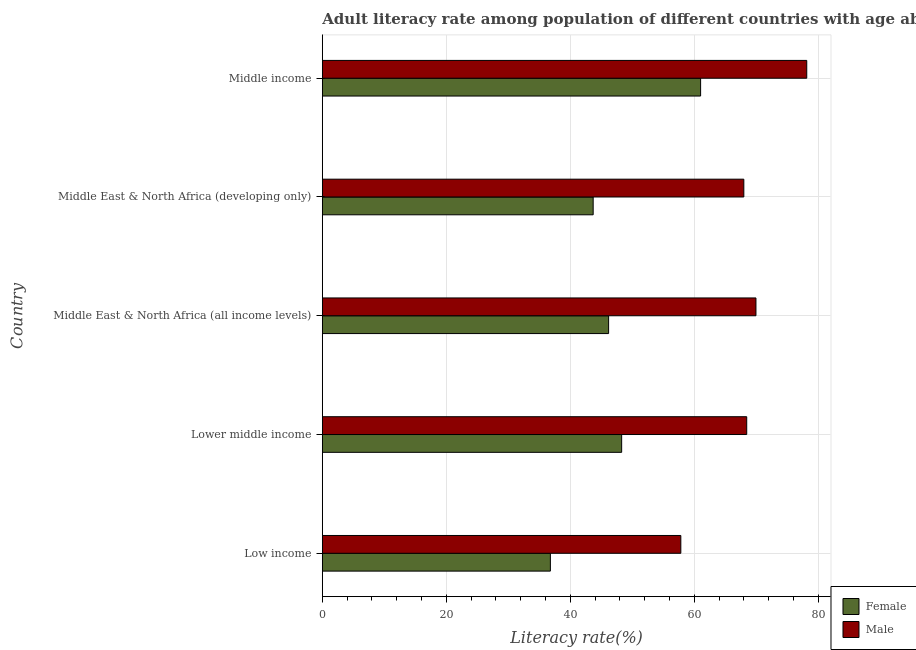How many different coloured bars are there?
Offer a very short reply. 2. How many bars are there on the 3rd tick from the bottom?
Give a very brief answer. 2. What is the label of the 4th group of bars from the top?
Make the answer very short. Lower middle income. In how many cases, is the number of bars for a given country not equal to the number of legend labels?
Your answer should be very brief. 0. What is the female adult literacy rate in Middle East & North Africa (developing only)?
Keep it short and to the point. 43.7. Across all countries, what is the maximum male adult literacy rate?
Keep it short and to the point. 78.16. Across all countries, what is the minimum male adult literacy rate?
Your response must be concise. 57.84. In which country was the female adult literacy rate maximum?
Ensure brevity in your answer.  Middle income. In which country was the female adult literacy rate minimum?
Ensure brevity in your answer.  Low income. What is the total male adult literacy rate in the graph?
Your response must be concise. 342.45. What is the difference between the female adult literacy rate in Low income and that in Lower middle income?
Provide a short and direct response. -11.5. What is the difference between the female adult literacy rate in Middle East & North Africa (developing only) and the male adult literacy rate in Low income?
Provide a short and direct response. -14.14. What is the average male adult literacy rate per country?
Ensure brevity in your answer.  68.49. What is the difference between the male adult literacy rate and female adult literacy rate in Middle income?
Offer a very short reply. 17.12. In how many countries, is the male adult literacy rate greater than 40 %?
Keep it short and to the point. 5. What is the ratio of the male adult literacy rate in Lower middle income to that in Middle income?
Make the answer very short. 0.88. What is the difference between the highest and the second highest male adult literacy rate?
Offer a terse response. 8.2. What is the difference between the highest and the lowest female adult literacy rate?
Offer a very short reply. 24.24. Is the sum of the male adult literacy rate in Low income and Middle East & North Africa (developing only) greater than the maximum female adult literacy rate across all countries?
Offer a terse response. Yes. How many bars are there?
Provide a succinct answer. 10. Are the values on the major ticks of X-axis written in scientific E-notation?
Provide a short and direct response. No. Does the graph contain any zero values?
Your answer should be compact. No. Does the graph contain grids?
Keep it short and to the point. Yes. How many legend labels are there?
Offer a very short reply. 2. How are the legend labels stacked?
Provide a succinct answer. Vertical. What is the title of the graph?
Your answer should be very brief. Adult literacy rate among population of different countries with age above 15years. Does "Diarrhea" appear as one of the legend labels in the graph?
Ensure brevity in your answer.  No. What is the label or title of the X-axis?
Offer a very short reply. Literacy rate(%). What is the Literacy rate(%) of Female in Low income?
Keep it short and to the point. 36.79. What is the Literacy rate(%) of Male in Low income?
Offer a very short reply. 57.84. What is the Literacy rate(%) of Female in Lower middle income?
Provide a short and direct response. 48.3. What is the Literacy rate(%) of Male in Lower middle income?
Your answer should be very brief. 68.47. What is the Literacy rate(%) in Female in Middle East & North Africa (all income levels)?
Provide a short and direct response. 46.19. What is the Literacy rate(%) of Male in Middle East & North Africa (all income levels)?
Keep it short and to the point. 69.96. What is the Literacy rate(%) of Female in Middle East & North Africa (developing only)?
Your response must be concise. 43.7. What is the Literacy rate(%) of Male in Middle East & North Africa (developing only)?
Provide a succinct answer. 68.01. What is the Literacy rate(%) of Female in Middle income?
Keep it short and to the point. 61.04. What is the Literacy rate(%) in Male in Middle income?
Offer a terse response. 78.16. Across all countries, what is the maximum Literacy rate(%) of Female?
Offer a terse response. 61.04. Across all countries, what is the maximum Literacy rate(%) in Male?
Offer a terse response. 78.16. Across all countries, what is the minimum Literacy rate(%) in Female?
Your answer should be very brief. 36.79. Across all countries, what is the minimum Literacy rate(%) of Male?
Make the answer very short. 57.84. What is the total Literacy rate(%) of Female in the graph?
Give a very brief answer. 236.01. What is the total Literacy rate(%) of Male in the graph?
Provide a short and direct response. 342.45. What is the difference between the Literacy rate(%) of Female in Low income and that in Lower middle income?
Provide a succinct answer. -11.5. What is the difference between the Literacy rate(%) in Male in Low income and that in Lower middle income?
Ensure brevity in your answer.  -10.63. What is the difference between the Literacy rate(%) of Female in Low income and that in Middle East & North Africa (all income levels)?
Your response must be concise. -9.4. What is the difference between the Literacy rate(%) in Male in Low income and that in Middle East & North Africa (all income levels)?
Your response must be concise. -12.12. What is the difference between the Literacy rate(%) of Female in Low income and that in Middle East & North Africa (developing only)?
Make the answer very short. -6.91. What is the difference between the Literacy rate(%) of Male in Low income and that in Middle East & North Africa (developing only)?
Give a very brief answer. -10.16. What is the difference between the Literacy rate(%) of Female in Low income and that in Middle income?
Give a very brief answer. -24.24. What is the difference between the Literacy rate(%) of Male in Low income and that in Middle income?
Your response must be concise. -20.32. What is the difference between the Literacy rate(%) in Female in Lower middle income and that in Middle East & North Africa (all income levels)?
Provide a short and direct response. 2.11. What is the difference between the Literacy rate(%) of Male in Lower middle income and that in Middle East & North Africa (all income levels)?
Provide a succinct answer. -1.49. What is the difference between the Literacy rate(%) in Female in Lower middle income and that in Middle East & North Africa (developing only)?
Make the answer very short. 4.6. What is the difference between the Literacy rate(%) of Male in Lower middle income and that in Middle East & North Africa (developing only)?
Provide a succinct answer. 0.47. What is the difference between the Literacy rate(%) in Female in Lower middle income and that in Middle income?
Give a very brief answer. -12.74. What is the difference between the Literacy rate(%) in Male in Lower middle income and that in Middle income?
Provide a succinct answer. -9.69. What is the difference between the Literacy rate(%) of Female in Middle East & North Africa (all income levels) and that in Middle East & North Africa (developing only)?
Offer a very short reply. 2.49. What is the difference between the Literacy rate(%) of Male in Middle East & North Africa (all income levels) and that in Middle East & North Africa (developing only)?
Provide a short and direct response. 1.96. What is the difference between the Literacy rate(%) in Female in Middle East & North Africa (all income levels) and that in Middle income?
Offer a terse response. -14.85. What is the difference between the Literacy rate(%) of Male in Middle East & North Africa (all income levels) and that in Middle income?
Your answer should be very brief. -8.2. What is the difference between the Literacy rate(%) of Female in Middle East & North Africa (developing only) and that in Middle income?
Offer a terse response. -17.34. What is the difference between the Literacy rate(%) in Male in Middle East & North Africa (developing only) and that in Middle income?
Provide a succinct answer. -10.15. What is the difference between the Literacy rate(%) in Female in Low income and the Literacy rate(%) in Male in Lower middle income?
Provide a short and direct response. -31.68. What is the difference between the Literacy rate(%) in Female in Low income and the Literacy rate(%) in Male in Middle East & North Africa (all income levels)?
Offer a terse response. -33.17. What is the difference between the Literacy rate(%) of Female in Low income and the Literacy rate(%) of Male in Middle East & North Africa (developing only)?
Your answer should be very brief. -31.21. What is the difference between the Literacy rate(%) of Female in Low income and the Literacy rate(%) of Male in Middle income?
Offer a terse response. -41.37. What is the difference between the Literacy rate(%) in Female in Lower middle income and the Literacy rate(%) in Male in Middle East & North Africa (all income levels)?
Offer a terse response. -21.67. What is the difference between the Literacy rate(%) in Female in Lower middle income and the Literacy rate(%) in Male in Middle East & North Africa (developing only)?
Give a very brief answer. -19.71. What is the difference between the Literacy rate(%) in Female in Lower middle income and the Literacy rate(%) in Male in Middle income?
Your answer should be very brief. -29.87. What is the difference between the Literacy rate(%) of Female in Middle East & North Africa (all income levels) and the Literacy rate(%) of Male in Middle East & North Africa (developing only)?
Offer a very short reply. -21.82. What is the difference between the Literacy rate(%) in Female in Middle East & North Africa (all income levels) and the Literacy rate(%) in Male in Middle income?
Your response must be concise. -31.97. What is the difference between the Literacy rate(%) in Female in Middle East & North Africa (developing only) and the Literacy rate(%) in Male in Middle income?
Provide a succinct answer. -34.46. What is the average Literacy rate(%) in Female per country?
Your answer should be compact. 47.2. What is the average Literacy rate(%) in Male per country?
Give a very brief answer. 68.49. What is the difference between the Literacy rate(%) of Female and Literacy rate(%) of Male in Low income?
Give a very brief answer. -21.05. What is the difference between the Literacy rate(%) of Female and Literacy rate(%) of Male in Lower middle income?
Provide a succinct answer. -20.18. What is the difference between the Literacy rate(%) of Female and Literacy rate(%) of Male in Middle East & North Africa (all income levels)?
Provide a succinct answer. -23.78. What is the difference between the Literacy rate(%) of Female and Literacy rate(%) of Male in Middle East & North Africa (developing only)?
Ensure brevity in your answer.  -24.31. What is the difference between the Literacy rate(%) in Female and Literacy rate(%) in Male in Middle income?
Provide a short and direct response. -17.12. What is the ratio of the Literacy rate(%) of Female in Low income to that in Lower middle income?
Ensure brevity in your answer.  0.76. What is the ratio of the Literacy rate(%) of Male in Low income to that in Lower middle income?
Give a very brief answer. 0.84. What is the ratio of the Literacy rate(%) of Female in Low income to that in Middle East & North Africa (all income levels)?
Make the answer very short. 0.8. What is the ratio of the Literacy rate(%) of Male in Low income to that in Middle East & North Africa (all income levels)?
Your response must be concise. 0.83. What is the ratio of the Literacy rate(%) in Female in Low income to that in Middle East & North Africa (developing only)?
Provide a short and direct response. 0.84. What is the ratio of the Literacy rate(%) of Male in Low income to that in Middle East & North Africa (developing only)?
Your response must be concise. 0.85. What is the ratio of the Literacy rate(%) in Female in Low income to that in Middle income?
Your answer should be compact. 0.6. What is the ratio of the Literacy rate(%) of Male in Low income to that in Middle income?
Your response must be concise. 0.74. What is the ratio of the Literacy rate(%) in Female in Lower middle income to that in Middle East & North Africa (all income levels)?
Offer a very short reply. 1.05. What is the ratio of the Literacy rate(%) of Male in Lower middle income to that in Middle East & North Africa (all income levels)?
Give a very brief answer. 0.98. What is the ratio of the Literacy rate(%) of Female in Lower middle income to that in Middle East & North Africa (developing only)?
Give a very brief answer. 1.11. What is the ratio of the Literacy rate(%) in Male in Lower middle income to that in Middle East & North Africa (developing only)?
Your answer should be very brief. 1.01. What is the ratio of the Literacy rate(%) in Female in Lower middle income to that in Middle income?
Your answer should be compact. 0.79. What is the ratio of the Literacy rate(%) of Male in Lower middle income to that in Middle income?
Your answer should be compact. 0.88. What is the ratio of the Literacy rate(%) in Female in Middle East & North Africa (all income levels) to that in Middle East & North Africa (developing only)?
Provide a succinct answer. 1.06. What is the ratio of the Literacy rate(%) of Male in Middle East & North Africa (all income levels) to that in Middle East & North Africa (developing only)?
Offer a terse response. 1.03. What is the ratio of the Literacy rate(%) of Female in Middle East & North Africa (all income levels) to that in Middle income?
Give a very brief answer. 0.76. What is the ratio of the Literacy rate(%) of Male in Middle East & North Africa (all income levels) to that in Middle income?
Provide a short and direct response. 0.9. What is the ratio of the Literacy rate(%) in Female in Middle East & North Africa (developing only) to that in Middle income?
Ensure brevity in your answer.  0.72. What is the ratio of the Literacy rate(%) of Male in Middle East & North Africa (developing only) to that in Middle income?
Provide a short and direct response. 0.87. What is the difference between the highest and the second highest Literacy rate(%) of Female?
Give a very brief answer. 12.74. What is the difference between the highest and the second highest Literacy rate(%) of Male?
Your answer should be very brief. 8.2. What is the difference between the highest and the lowest Literacy rate(%) in Female?
Ensure brevity in your answer.  24.24. What is the difference between the highest and the lowest Literacy rate(%) of Male?
Your answer should be very brief. 20.32. 